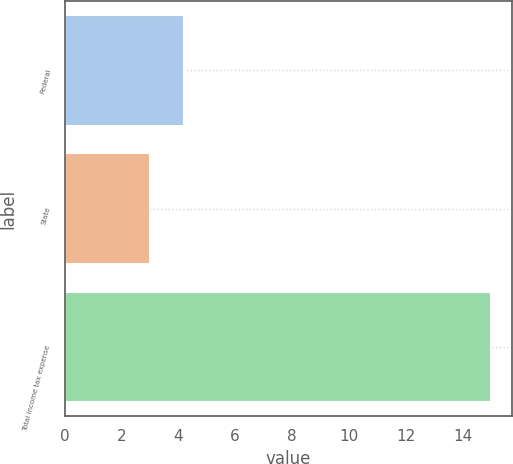<chart> <loc_0><loc_0><loc_500><loc_500><bar_chart><fcel>Federal<fcel>State<fcel>Total income tax expense<nl><fcel>4.2<fcel>3<fcel>15<nl></chart> 